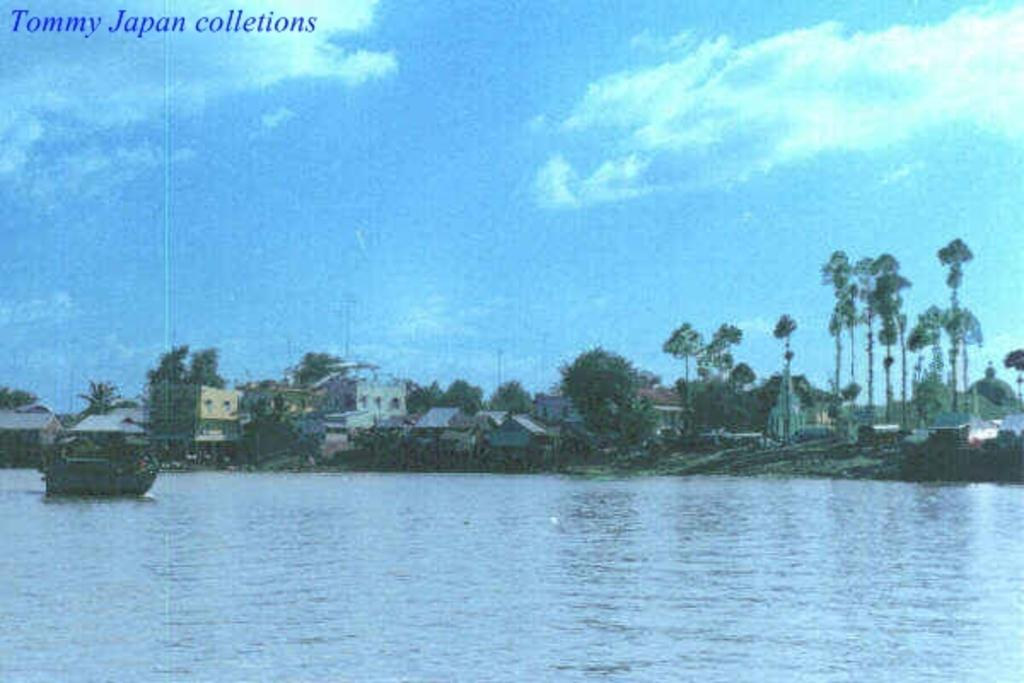What body of water is present in the image? There is a river in the image. What is in the river? There is a boat in the river. What can be seen in the background of the image? There are houses and trees in the background of the image. What color is the sky in the background of the image? The sky is blue in the background of the image. What is present in the top left corner of the image? There is text in the top left corner of the image. Where is the playground located in the image? There is no playground present in the image. What type of wine is being served on the boat in the image? There is no wine present in the image, and the boat does not appear to be serving any food or beverages. 